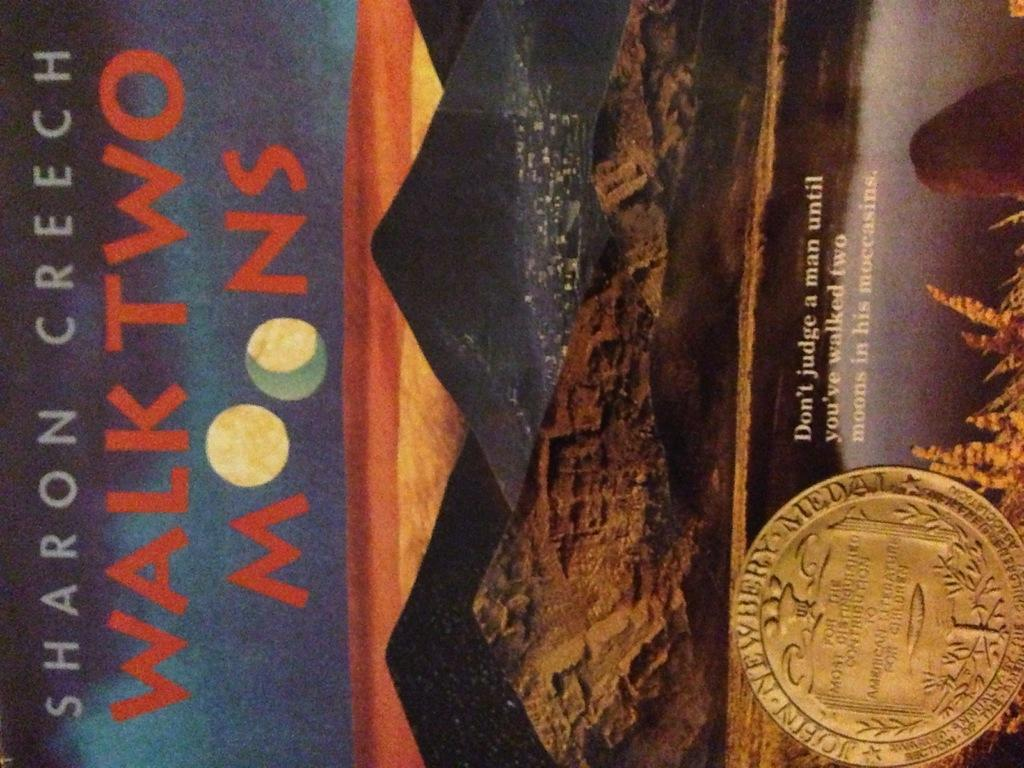<image>
Describe the image concisely. The title of the book is Walk Two Moons 